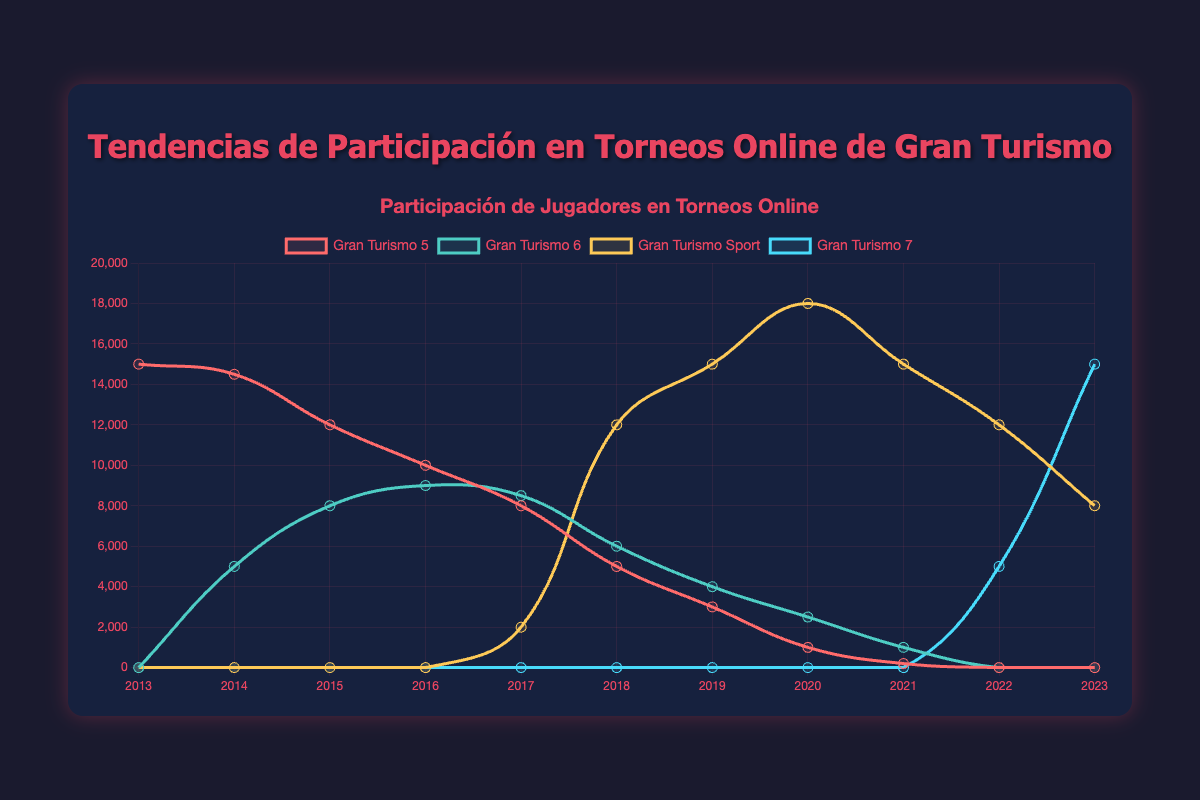What's the average participation in Gran Turismo Sport for the years it was active? Gran Turismo Sport was only active from 2017 to 2023. The player counts for these years are: 2000, 12000, 15000, 18000, 15000, 12000, 8000. Sum them up (2000 + 12000 + 15000 + 18000 + 15000 + 12000 + 8000) = 82000. There are 7 years, so the average is 82000/7 = 11714.29
Answer: 11714.29 Which year had the highest total player participation for all games combined? Sum the player participation for each year across all games. The year with the highest total will be the answer. 2017 has the highest total with Gran Turismo 5 (8000), Gran Turismo 6 (8500), and Gran Turismo Sport (2000): 8000 + 8500 + 2000 = 18500.
Answer: 2017 In which year did Gran Turismo 7 surpass Gran Turismo Sport in player participation? Look at the player participation in Gran Turismo 7 and Gran Turismo Sport year by year. Gran Turismo 7 only surpassed Gran Turismo Sport in 2023: Gran Turismo 7 (15000) and Gran Turismo Sport (8000).
Answer: 2023 What was the decline in player participation for Gran Turismo 5 from 2013 to 2020? Subtract the player participation in 2020 from that in 2013: 15000 (2013 player count) - 1000 (2020 player count) = 14000
Answer: 14000 Which game had the most stable participation without major fluctuations over the years? By observing the trends, Gran Turismo 6 had relatively stable participation compared to others, mainly fluctuating between 1000 and 9000, without dramatic increases or decreases.
Answer: Gran Turismo 6 In what year did Gran Turismo 5 experience the steepest decline in player participation? Analyze the year-over-year decline for Gran Turismo 5. The steepest decline was between 2014 and 2015, dropping from 14500 to 12000, with a difference of 2500.
Answer: 2014-2015 How did the player participation trend for Gran Turismo Sport change from launch until 2023? Gran Turismo Sport launched with 2000 players in 2017, increasing to 12000 in 2018, peaking at 18000 in 2020, and then declining to 8000 by 2023.
Answer: Increased, then declined Which game had no players in 2022? Check the data for each game in 2022. Both Gran Turismo 5 and Gran Turismo 6 had 0 players.
Answer: Gran Turismo 5 and Gran Turismo 6 Compare the player participation in 2020 for Gran Turismo Sport and Gran Turismo 6. Which had more players and by how much? Gran Turismo Sport had 18000 players and Gran Turismo 6 had 2500 players in 2020. The difference is 18000 - 2500 = 15500. Gran Turismo Sport had 15500 more players.
Answer: Gran Turismo Sport, 15500 In 2018, which game had the most significant increase in player participation compared to the previous year? Compare the increase in players from 2017 to 2018 for each game. Gran Turismo Sport had the most significant increase, from 2000 to 12000, an increase of 10000 players.
Answer: Gran Turismo Sport 